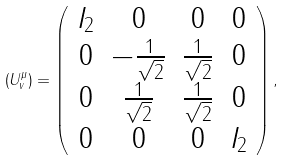Convert formula to latex. <formula><loc_0><loc_0><loc_500><loc_500>\left ( U _ { v } ^ { \mu } \right ) = \left ( \begin{array} { c c c c } { I } _ { 2 } & 0 & 0 & 0 \\ 0 & - \frac { 1 } { \sqrt { 2 } } & \frac { 1 } { \sqrt { 2 } } & 0 \\ 0 & \frac { 1 } { \sqrt { 2 } } & \frac { 1 } { \sqrt { 2 } } & 0 \\ 0 & 0 & 0 & { I } _ { 2 } \end{array} \right ) ,</formula> 